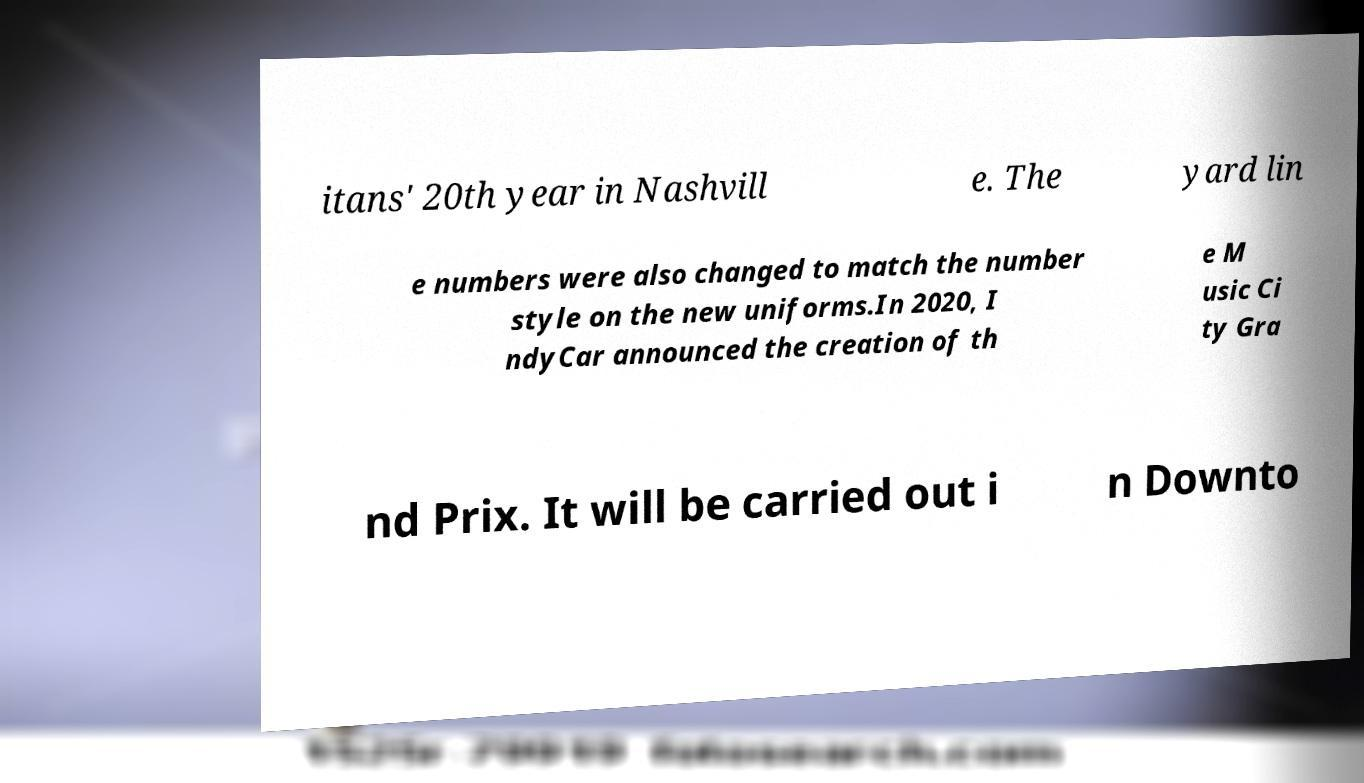There's text embedded in this image that I need extracted. Can you transcribe it verbatim? itans' 20th year in Nashvill e. The yard lin e numbers were also changed to match the number style on the new uniforms.In 2020, I ndyCar announced the creation of th e M usic Ci ty Gra nd Prix. It will be carried out i n Downto 